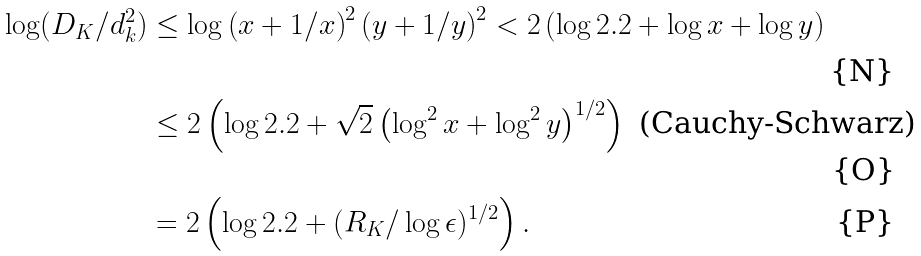Convert formula to latex. <formula><loc_0><loc_0><loc_500><loc_500>\log ( D _ { K } / d _ { k } ^ { 2 } ) & \leq \log \left ( x + 1 / x \right ) ^ { 2 } \left ( y + 1 / y \right ) ^ { 2 } < 2 \left ( \log 2 . 2 + \log x + \log y \right ) \\ & \leq 2 \left ( \log 2 . 2 + \sqrt { 2 } \left ( \log ^ { 2 } x + \log ^ { 2 } y \right ) ^ { 1 / 2 } \right ) \text { (Cauchy-Schwarz)} \\ & = 2 \left ( \log 2 . 2 + ( R _ { K } / \log \epsilon ) ^ { 1 / 2 } \right ) .</formula> 